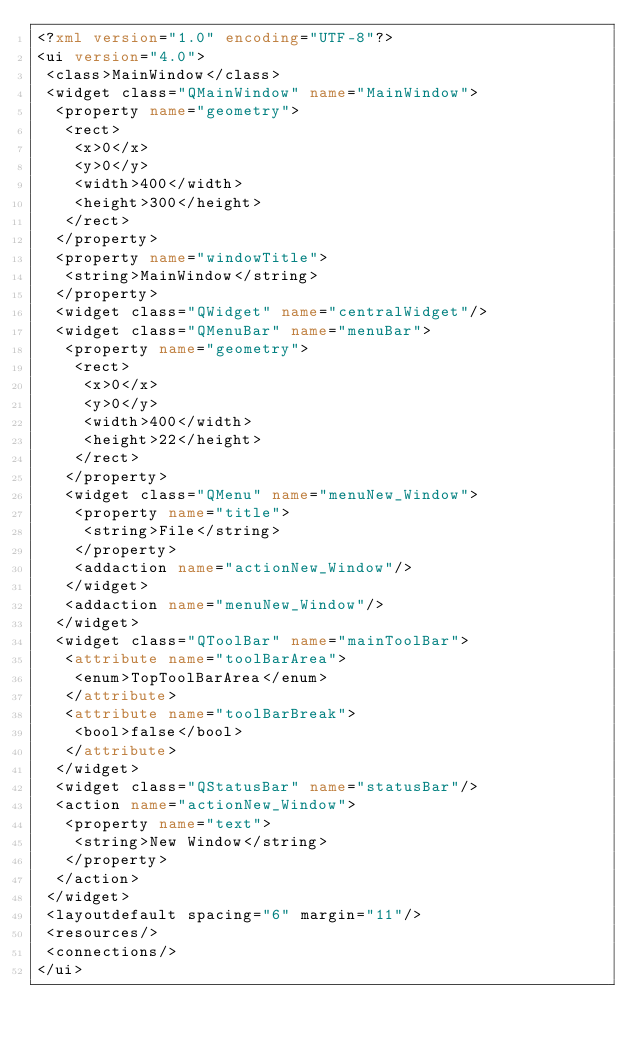<code> <loc_0><loc_0><loc_500><loc_500><_XML_><?xml version="1.0" encoding="UTF-8"?>
<ui version="4.0">
 <class>MainWindow</class>
 <widget class="QMainWindow" name="MainWindow">
  <property name="geometry">
   <rect>
    <x>0</x>
    <y>0</y>
    <width>400</width>
    <height>300</height>
   </rect>
  </property>
  <property name="windowTitle">
   <string>MainWindow</string>
  </property>
  <widget class="QWidget" name="centralWidget"/>
  <widget class="QMenuBar" name="menuBar">
   <property name="geometry">
    <rect>
     <x>0</x>
     <y>0</y>
     <width>400</width>
     <height>22</height>
    </rect>
   </property>
   <widget class="QMenu" name="menuNew_Window">
    <property name="title">
     <string>File</string>
    </property>
    <addaction name="actionNew_Window"/>
   </widget>
   <addaction name="menuNew_Window"/>
  </widget>
  <widget class="QToolBar" name="mainToolBar">
   <attribute name="toolBarArea">
    <enum>TopToolBarArea</enum>
   </attribute>
   <attribute name="toolBarBreak">
    <bool>false</bool>
   </attribute>
  </widget>
  <widget class="QStatusBar" name="statusBar"/>
  <action name="actionNew_Window">
   <property name="text">
    <string>New Window</string>
   </property>
  </action>
 </widget>
 <layoutdefault spacing="6" margin="11"/>
 <resources/>
 <connections/>
</ui>
</code> 